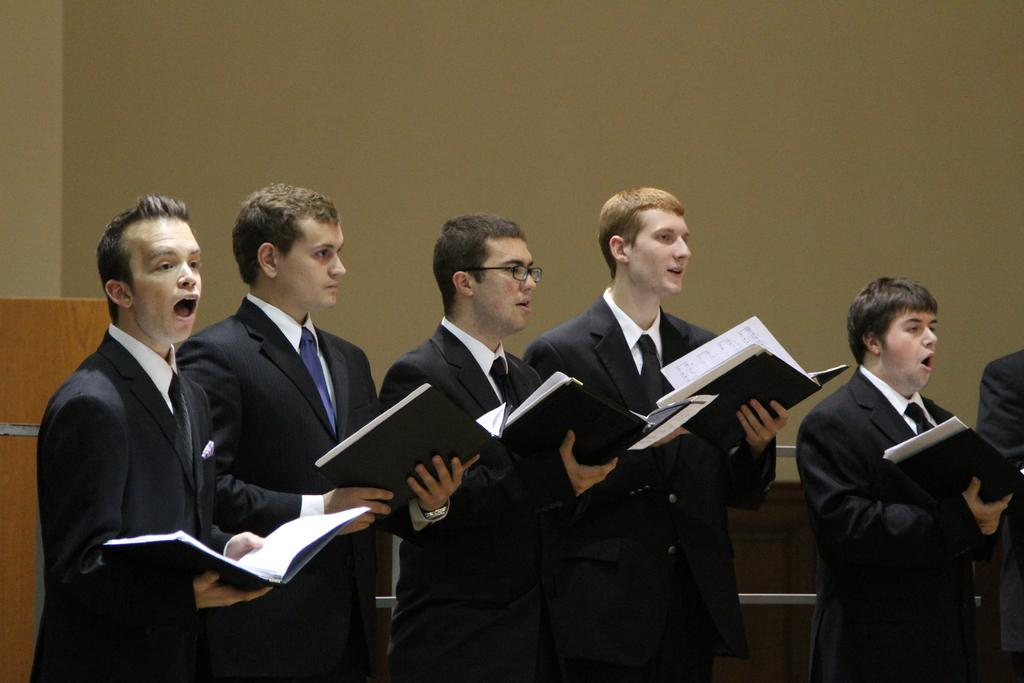What is happening in the image involving the group of people? The people in the image are standing and holding books. What can be seen in the hands of the people in the image? The people are holding books in their hands. What type of object is made of wood and visible in the image? There is a wooden object in the image. What is visible in the background of the image? There is a wall in the background of the image. What type of banana is being used as a prop in the image? There is no banana present in the image; the people are holding books. Can you tell me how many blades are visible in the image? There are no blades visible in the image; the wooden object and books are the main objects present. 